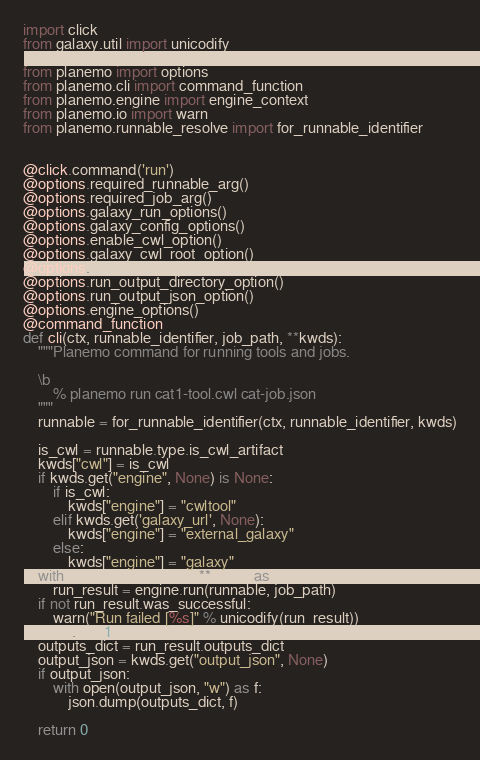Convert code to text. <code><loc_0><loc_0><loc_500><loc_500><_Python_>
import click
from galaxy.util import unicodify

from planemo import options
from planemo.cli import command_function
from planemo.engine import engine_context
from planemo.io import warn
from planemo.runnable_resolve import for_runnable_identifier


@click.command('run')
@options.required_runnable_arg()
@options.required_job_arg()
@options.galaxy_run_options()
@options.galaxy_config_options()
@options.enable_cwl_option()
@options.galaxy_cwl_root_option()
@options.run_history_tags_option()
@options.run_output_directory_option()
@options.run_output_json_option()
@options.engine_options()
@command_function
def cli(ctx, runnable_identifier, job_path, **kwds):
    """Planemo command for running tools and jobs.

    \b
        % planemo run cat1-tool.cwl cat-job.json
    """
    runnable = for_runnable_identifier(ctx, runnable_identifier, kwds)

    is_cwl = runnable.type.is_cwl_artifact
    kwds["cwl"] = is_cwl
    if kwds.get("engine", None) is None:
        if is_cwl:
            kwds["engine"] = "cwltool"
        elif kwds.get('galaxy_url', None):
            kwds["engine"] = "external_galaxy"
        else:
            kwds["engine"] = "galaxy"
    with engine_context(ctx, **kwds) as engine:
        run_result = engine.run(runnable, job_path)
    if not run_result.was_successful:
        warn("Run failed [%s]" % unicodify(run_result))
        ctx.exit(1)
    outputs_dict = run_result.outputs_dict
    output_json = kwds.get("output_json", None)
    if output_json:
        with open(output_json, "w") as f:
            json.dump(outputs_dict, f)

    return 0
</code> 